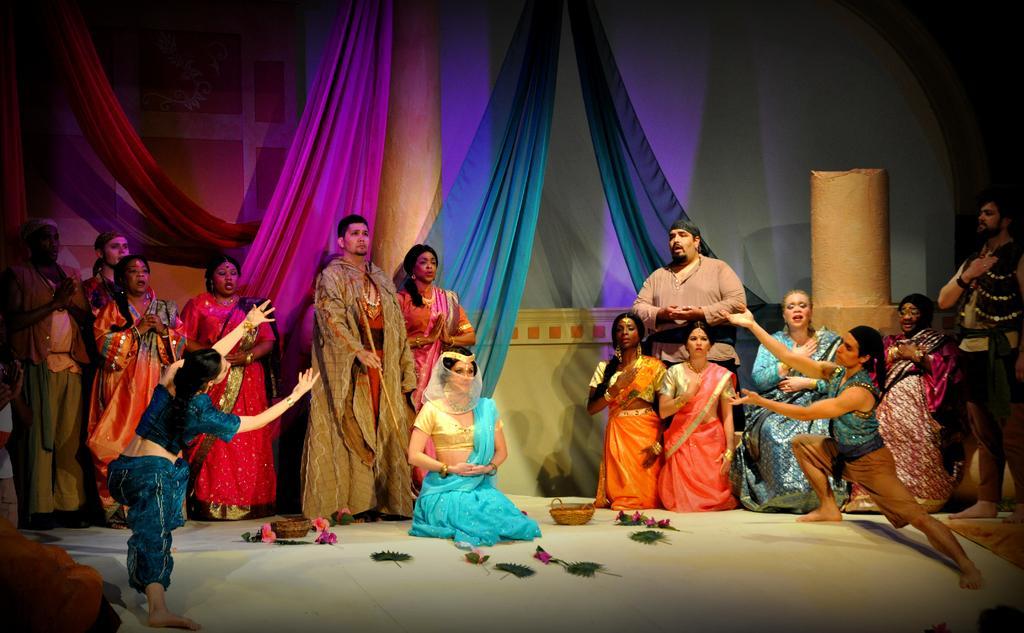Please provide a concise description of this image. In this image I can see number of people and I can see all of them are wearing costumes. In the background I can see few curtains and I can also see few baskets over here. 